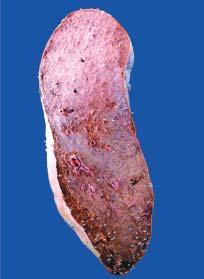s the spleen heavy and enlarged in size?
Answer the question using a single word or phrase. Yes 